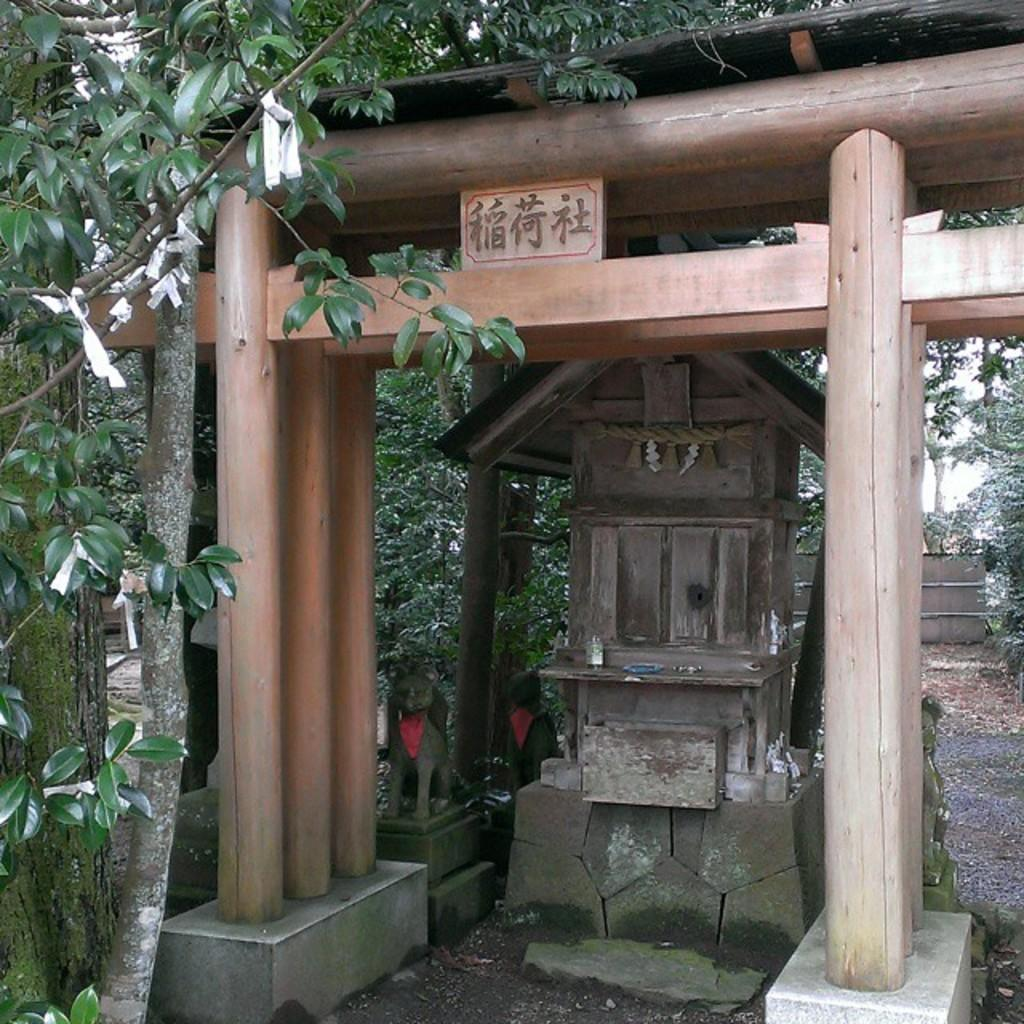What type of structure is in the image? There is a wooden shed in the image. Is there any text or writing on the wooden shed? Yes, something is written on the wooden shed. What other structures are near the wooden shed? There is a small hut-like structure below the wooden shed and a statue near the wooden shed. What can be seen in the background of the wooden shed? Trees are present on the sides of the wooden shed. What type of flesh can be seen on the statue near the wooden shed? There is no flesh visible on the statue in the image, as it is likely made of a material like stone or metal. 